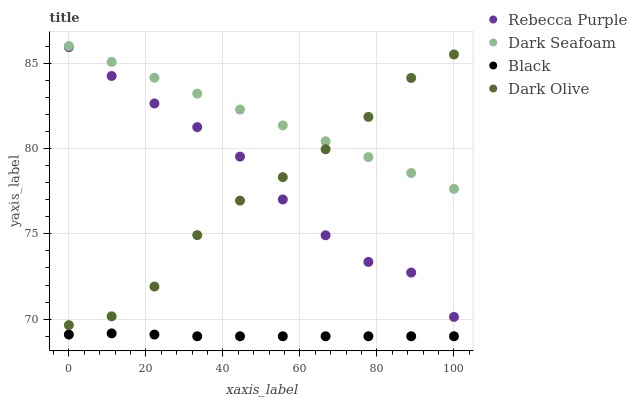Does Black have the minimum area under the curve?
Answer yes or no. Yes. Does Dark Seafoam have the maximum area under the curve?
Answer yes or no. Yes. Does Dark Olive have the minimum area under the curve?
Answer yes or no. No. Does Dark Olive have the maximum area under the curve?
Answer yes or no. No. Is Dark Seafoam the smoothest?
Answer yes or no. Yes. Is Dark Olive the roughest?
Answer yes or no. Yes. Is Black the smoothest?
Answer yes or no. No. Is Black the roughest?
Answer yes or no. No. Does Black have the lowest value?
Answer yes or no. Yes. Does Dark Olive have the lowest value?
Answer yes or no. No. Does Dark Seafoam have the highest value?
Answer yes or no. Yes. Does Dark Olive have the highest value?
Answer yes or no. No. Is Rebecca Purple less than Dark Seafoam?
Answer yes or no. Yes. Is Dark Seafoam greater than Rebecca Purple?
Answer yes or no. Yes. Does Dark Olive intersect Dark Seafoam?
Answer yes or no. Yes. Is Dark Olive less than Dark Seafoam?
Answer yes or no. No. Is Dark Olive greater than Dark Seafoam?
Answer yes or no. No. Does Rebecca Purple intersect Dark Seafoam?
Answer yes or no. No. 